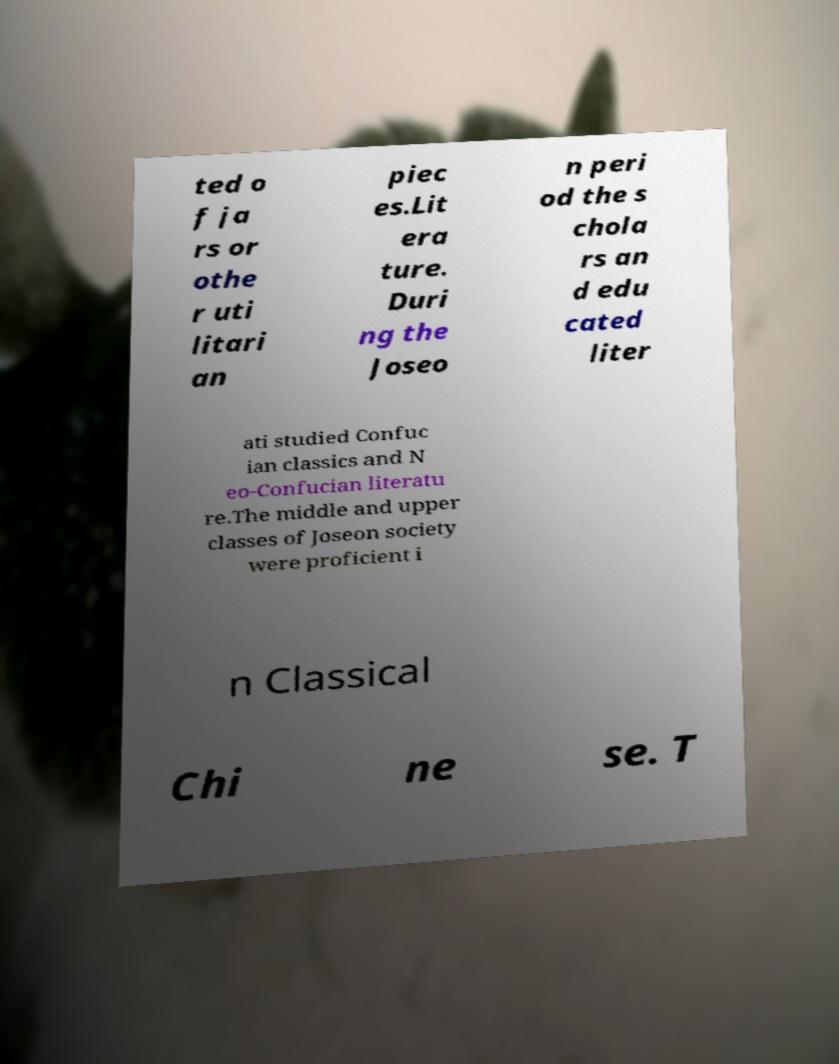For documentation purposes, I need the text within this image transcribed. Could you provide that? ted o f ja rs or othe r uti litari an piec es.Lit era ture. Duri ng the Joseo n peri od the s chola rs an d edu cated liter ati studied Confuc ian classics and N eo-Confucian literatu re.The middle and upper classes of Joseon society were proficient i n Classical Chi ne se. T 